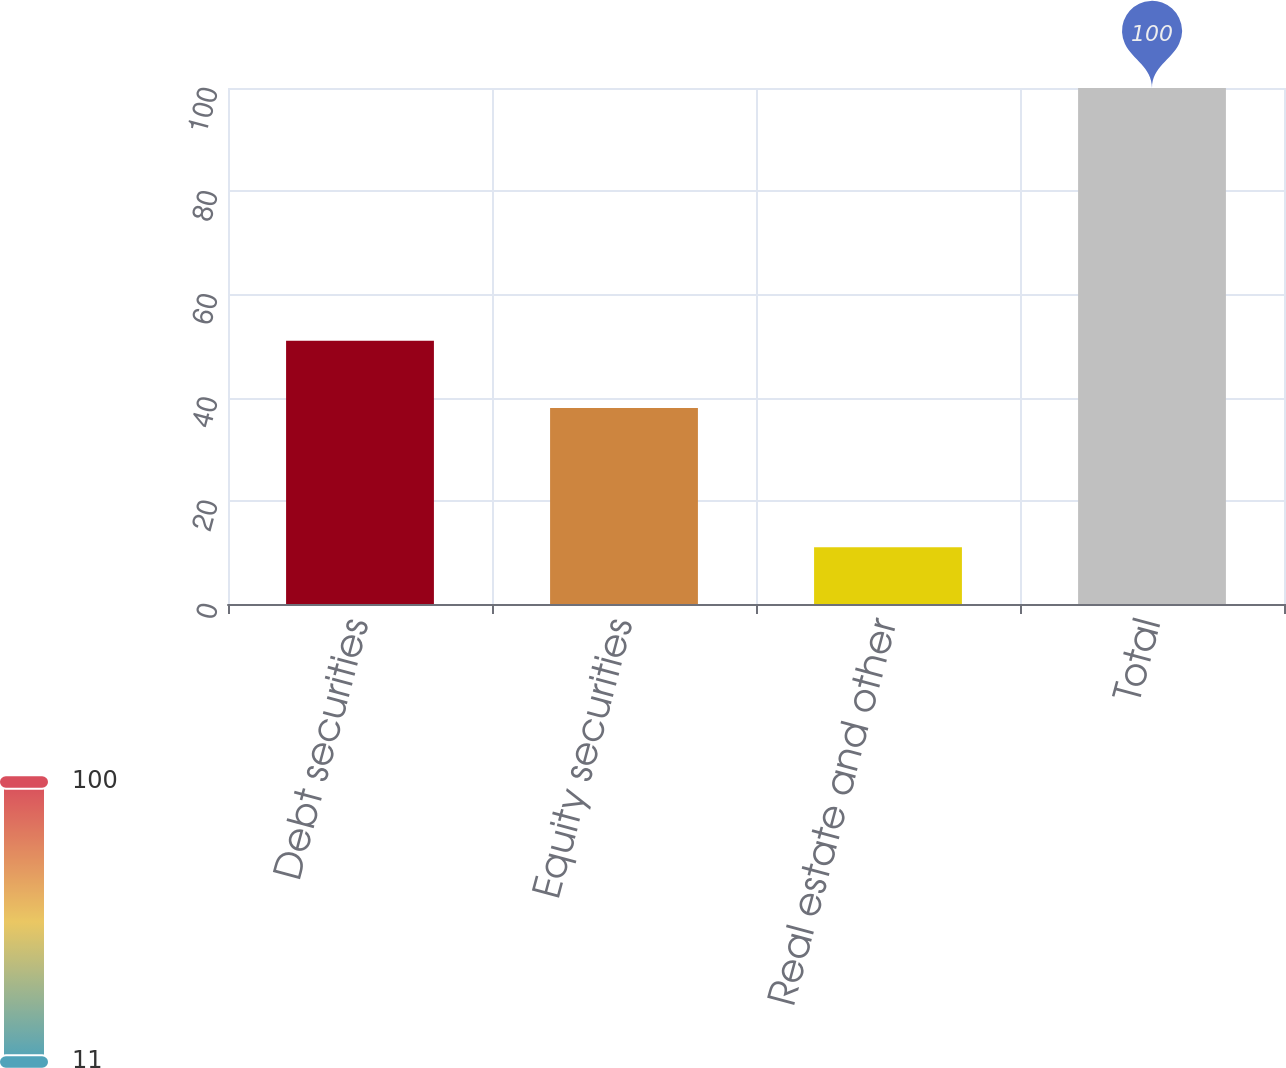Convert chart to OTSL. <chart><loc_0><loc_0><loc_500><loc_500><bar_chart><fcel>Debt securities<fcel>Equity securities<fcel>Real estate and other<fcel>Total<nl><fcel>51<fcel>38<fcel>11<fcel>100<nl></chart> 